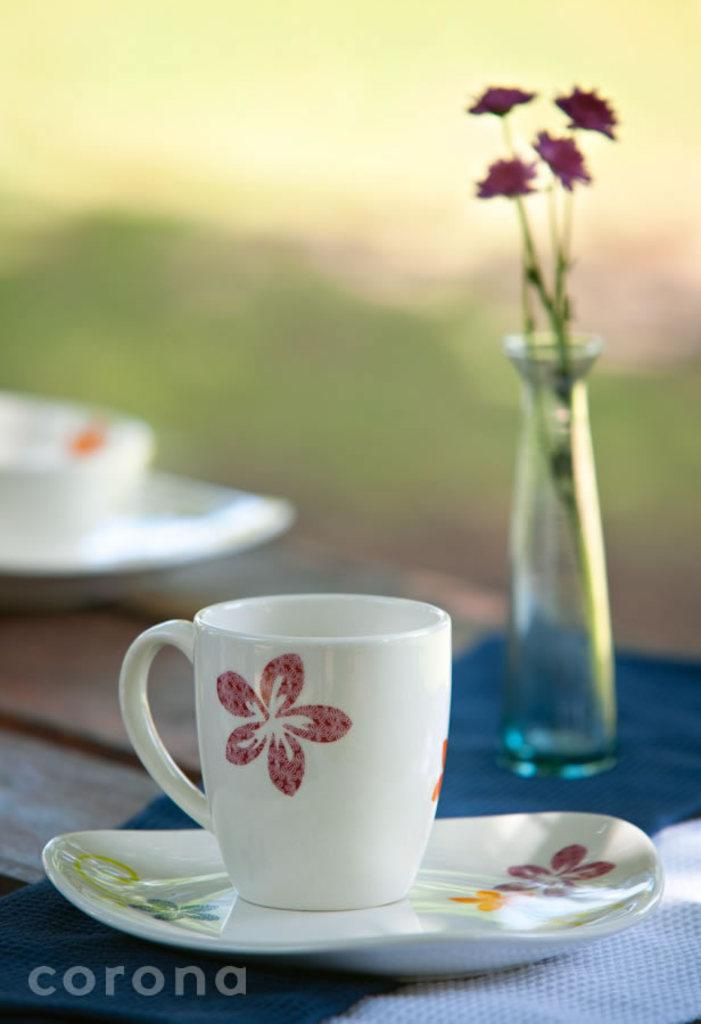What objects are present on the table in the image? There are cups, saucers, a flower vase, and napkins on the table in the image. What might be used for holding liquids in the image? The cups on the table can be used for holding liquids. What is the purpose of the saucers in the image? The saucers in the image are likely used to hold cups or provide a surface for placing cups on the tableware. What can be seen in the background of the image? The background of the image is blurred. What is the nature of the watermark on the image? The watermark on the image is a mark or logo that indicates ownership or copyright. What type of ball is being used as a centerpiece in the image? There is no ball present in the image; it features cups, saucers, a flower vase, and napkins on a table. What is the zinc content of the cups in the image? The zinc content of the cups cannot be determined from the image, as it does not provide information about the materials used in their construction. 